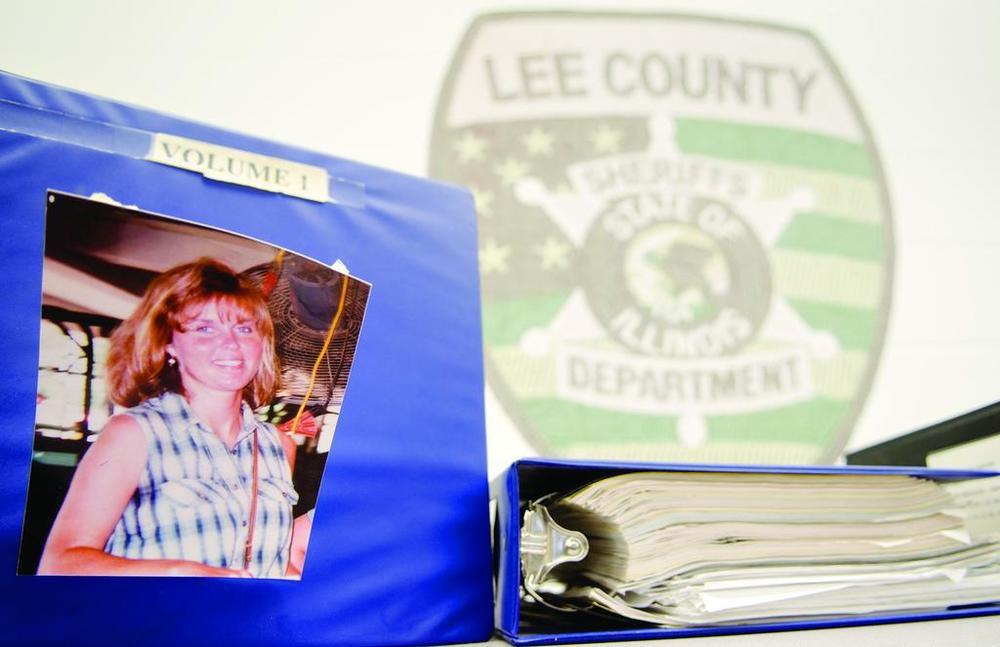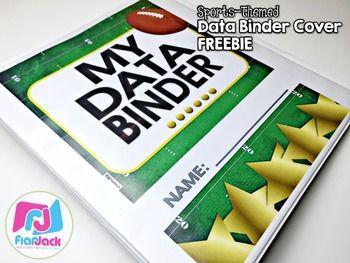The first image is the image on the left, the second image is the image on the right. Analyze the images presented: Is the assertion "there are at least five colored binders in the image on the left" valid? Answer yes or no. No. The first image is the image on the left, the second image is the image on the right. Assess this claim about the two images: "A person is grasping a vertical stack of binders in one image.". Correct or not? Answer yes or no. No. 